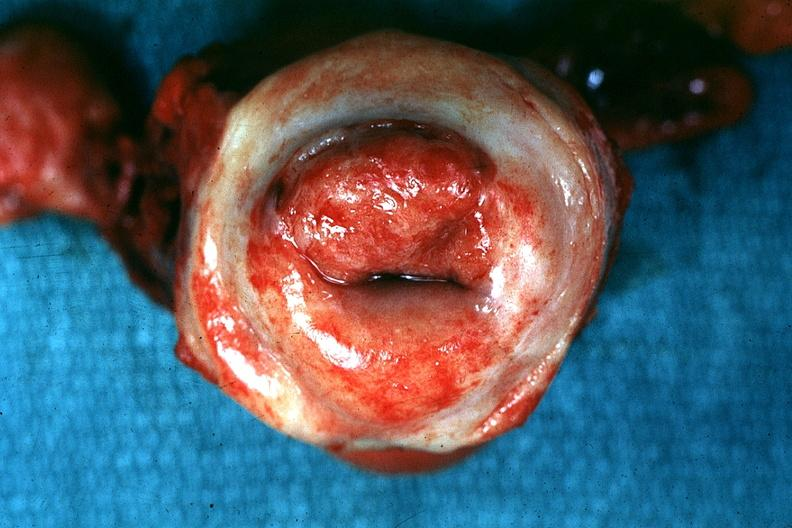how is excellent example tumor labeled as?
Answer the question using a single word or phrase. Invasive 